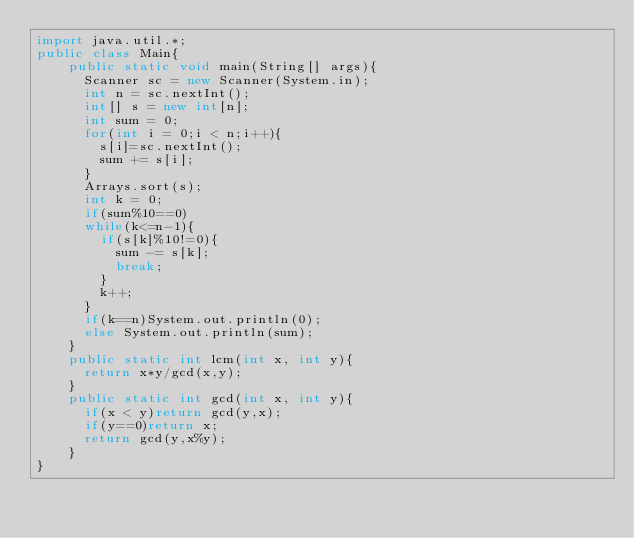Convert code to text. <code><loc_0><loc_0><loc_500><loc_500><_Java_>import java.util.*;
public class Main{   
    public static void main(String[] args){
      Scanner sc = new Scanner(System.in);
      int n = sc.nextInt();
      int[] s = new int[n];
      int sum = 0;
      for(int i = 0;i < n;i++){
        s[i]=sc.nextInt();
        sum += s[i];
      }
      Arrays.sort(s);
      int k = 0;
      if(sum%10==0)
      while(k<=n-1){
      	if(s[k]%10!=0){
          sum -= s[k];
          break;
        }
        k++;
      }
      if(k==n)System.out.println(0);
      else System.out.println(sum);
    }
    public static int lcm(int x, int y){
      return x*y/gcd(x,y);
    }
    public static int gcd(int x, int y){
      if(x < y)return gcd(y,x);
      if(y==0)return x;
      return gcd(y,x%y);
    }
}</code> 